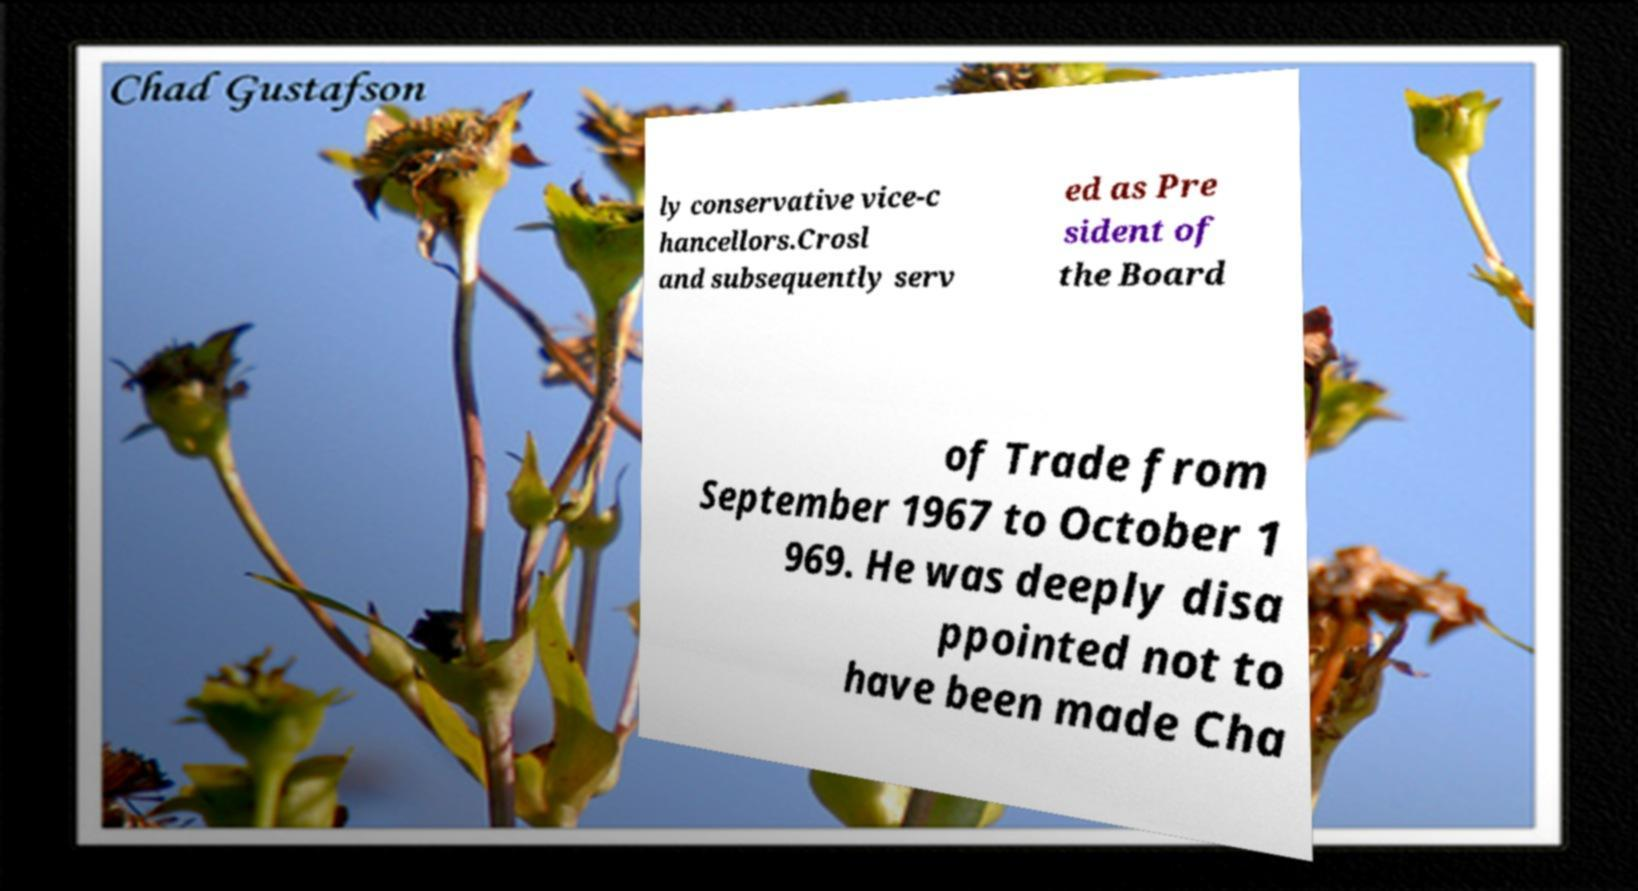For documentation purposes, I need the text within this image transcribed. Could you provide that? ly conservative vice-c hancellors.Crosl and subsequently serv ed as Pre sident of the Board of Trade from September 1967 to October 1 969. He was deeply disa ppointed not to have been made Cha 